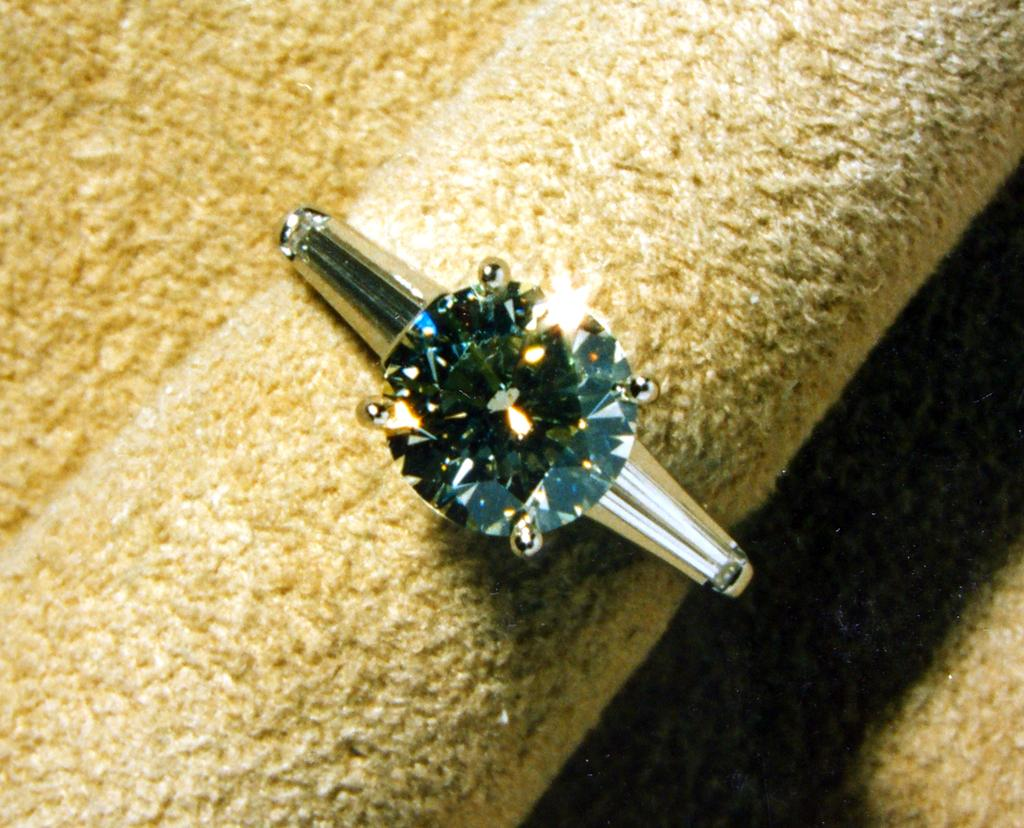What is the main object in the image? There is a ring in the image. What is located at the bottom of the image? There is a cloth at the bottom of the image. What type of blade is being used for the fact-checking voyage in the image? There is no blade or voyage present in the image; it only features a ring and a cloth. 